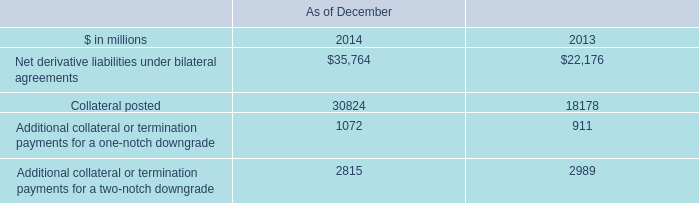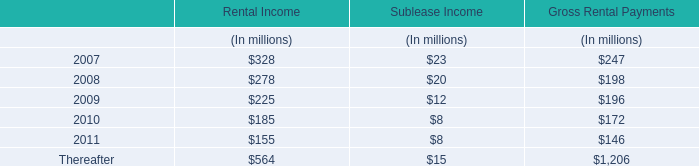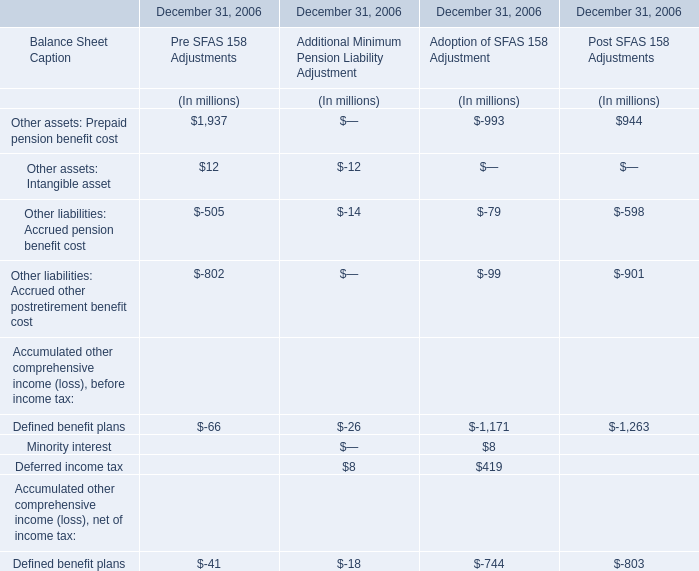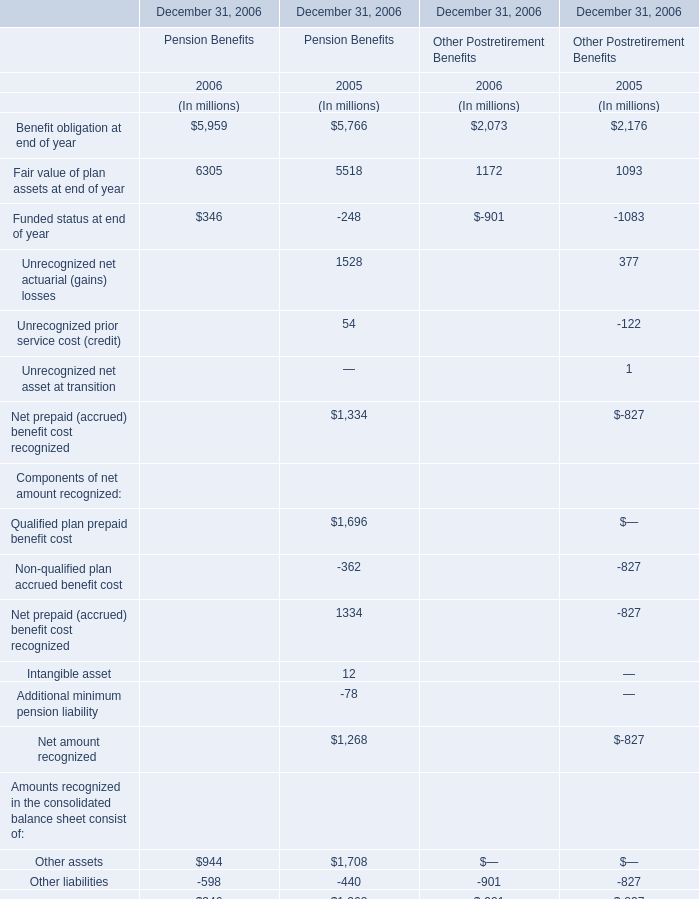What is the highest total amount of Other assets: Intangible asset as of December 31, 2006? (in million) 
Answer: 12. 